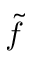<formula> <loc_0><loc_0><loc_500><loc_500>\tilde { f }</formula> 